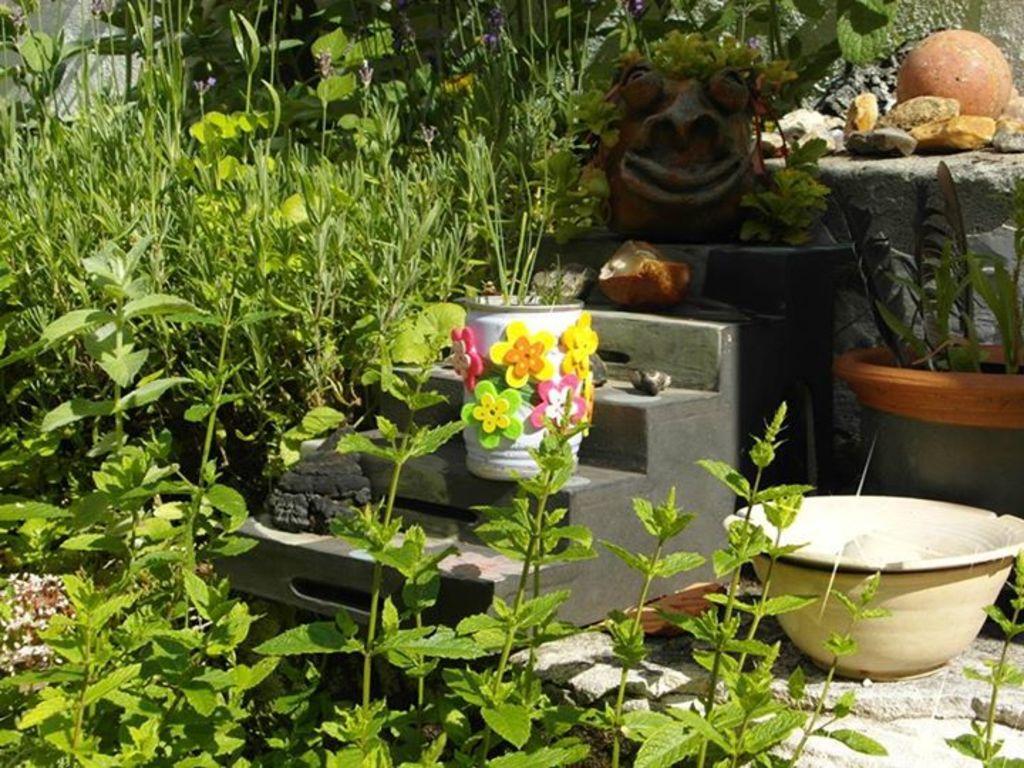Please provide a concise description of this image. In this picture we can see the plants, pots. We can see the objects and a colorful pot on the stairs. We can see the pebbles. 